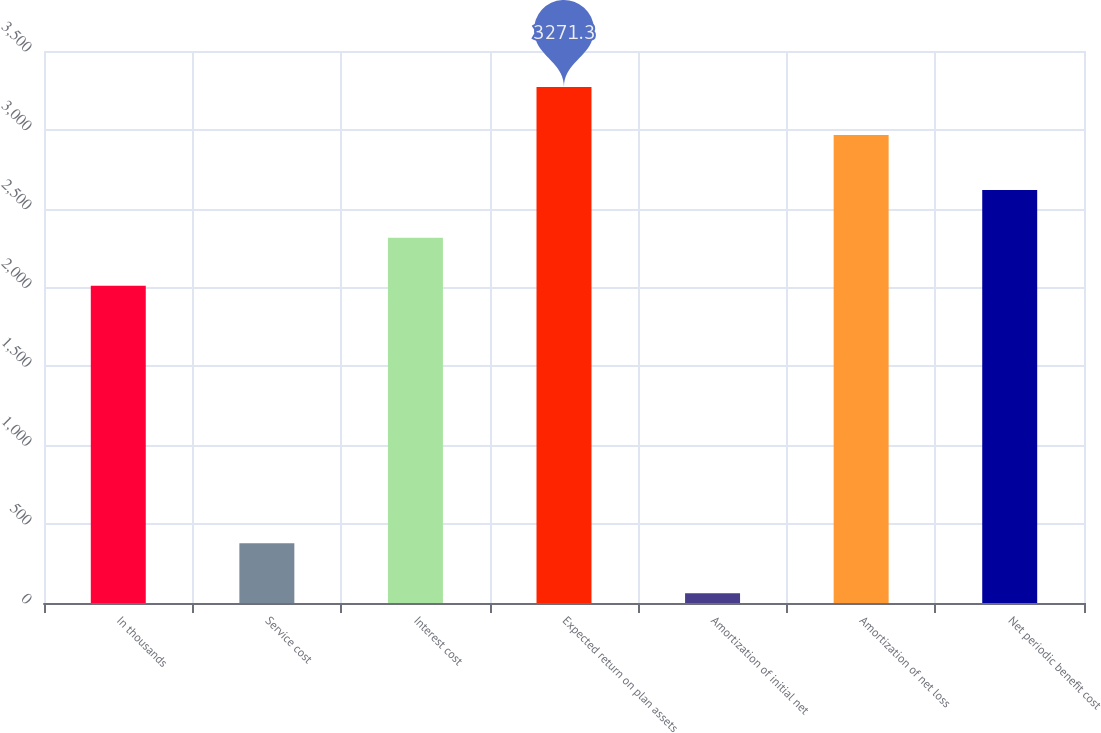<chart> <loc_0><loc_0><loc_500><loc_500><bar_chart><fcel>In thousands<fcel>Service cost<fcel>Interest cost<fcel>Expected return on plan assets<fcel>Amortization of initial net<fcel>Amortization of net loss<fcel>Net periodic benefit cost<nl><fcel>2012<fcel>379<fcel>2315.3<fcel>3271.3<fcel>62<fcel>2968<fcel>2618.6<nl></chart> 